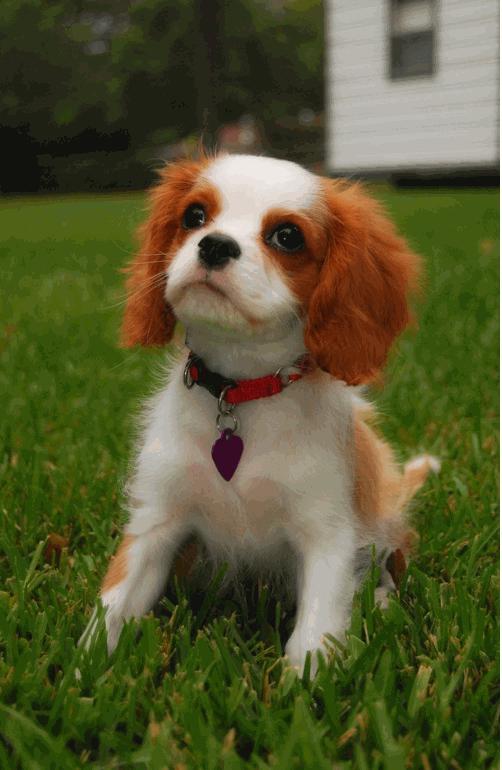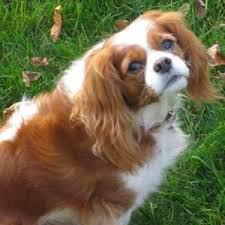The first image is the image on the left, the second image is the image on the right. Considering the images on both sides, is "Each image shows an orange-and-white spaniel on green grass, and the left image shows a dog sitting upright with body angled leftward." valid? Answer yes or no. Yes. The first image is the image on the left, the second image is the image on the right. Considering the images on both sides, is "One dog is laying down." valid? Answer yes or no. No. 